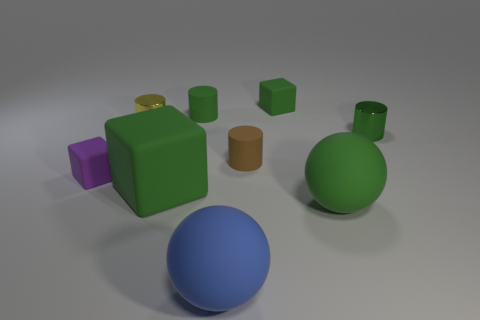Add 1 tiny yellow metal cylinders. How many objects exist? 10 Subtract all tiny yellow metallic cylinders. How many cylinders are left? 3 Subtract all blocks. How many objects are left? 6 Subtract all tiny brown cylinders. Subtract all big yellow rubber cylinders. How many objects are left? 8 Add 5 brown rubber cylinders. How many brown rubber cylinders are left? 6 Add 8 small green cylinders. How many small green cylinders exist? 10 Subtract all green spheres. How many spheres are left? 1 Subtract 0 red blocks. How many objects are left? 9 Subtract 2 cylinders. How many cylinders are left? 2 Subtract all purple cylinders. Subtract all yellow spheres. How many cylinders are left? 4 